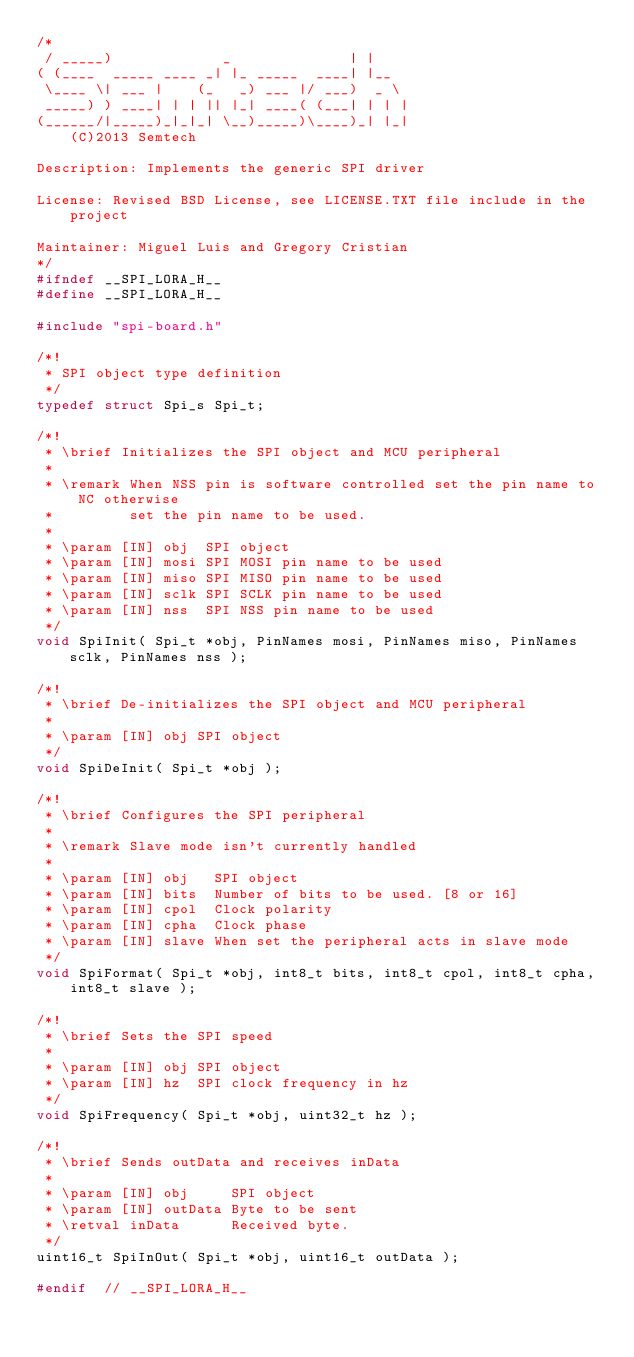Convert code to text. <code><loc_0><loc_0><loc_500><loc_500><_C_>/*
 / _____)             _              | |
( (____  _____ ____ _| |_ _____  ____| |__
 \____ \| ___ |    (_   _) ___ |/ ___)  _ \
 _____) ) ____| | | || |_| ____( (___| | | |
(______/|_____)_|_|_| \__)_____)\____)_| |_|
    (C)2013 Semtech

Description: Implements the generic SPI driver

License: Revised BSD License, see LICENSE.TXT file include in the project

Maintainer: Miguel Luis and Gregory Cristian
*/
#ifndef __SPI_LORA_H__
#define __SPI_LORA_H__

#include "spi-board.h"

/*!
 * SPI object type definition
 */
typedef struct Spi_s Spi_t;

/*!
 * \brief Initializes the SPI object and MCU peripheral
 *
 * \remark When NSS pin is software controlled set the pin name to NC otherwise
 *         set the pin name to be used.
 *
 * \param [IN] obj  SPI object
 * \param [IN] mosi SPI MOSI pin name to be used
 * \param [IN] miso SPI MISO pin name to be used
 * \param [IN] sclk SPI SCLK pin name to be used
 * \param [IN] nss  SPI NSS pin name to be used
 */
void SpiInit( Spi_t *obj, PinNames mosi, PinNames miso, PinNames sclk, PinNames nss );

/*!
 * \brief De-initializes the SPI object and MCU peripheral
 *
 * \param [IN] obj SPI object
 */
void SpiDeInit( Spi_t *obj );

/*!
 * \brief Configures the SPI peripheral
 *
 * \remark Slave mode isn't currently handled
 *
 * \param [IN] obj   SPI object
 * \param [IN] bits  Number of bits to be used. [8 or 16]
 * \param [IN] cpol  Clock polarity
 * \param [IN] cpha  Clock phase
 * \param [IN] slave When set the peripheral acts in slave mode
 */
void SpiFormat( Spi_t *obj, int8_t bits, int8_t cpol, int8_t cpha, int8_t slave );

/*!
 * \brief Sets the SPI speed
 *
 * \param [IN] obj SPI object
 * \param [IN] hz  SPI clock frequency in hz
 */
void SpiFrequency( Spi_t *obj, uint32_t hz );

/*!
 * \brief Sends outData and receives inData
 *
 * \param [IN] obj     SPI object
 * \param [IN] outData Byte to be sent
 * \retval inData      Received byte.
 */
uint16_t SpiInOut( Spi_t *obj, uint16_t outData );

#endif  // __SPI_LORA_H__
</code> 